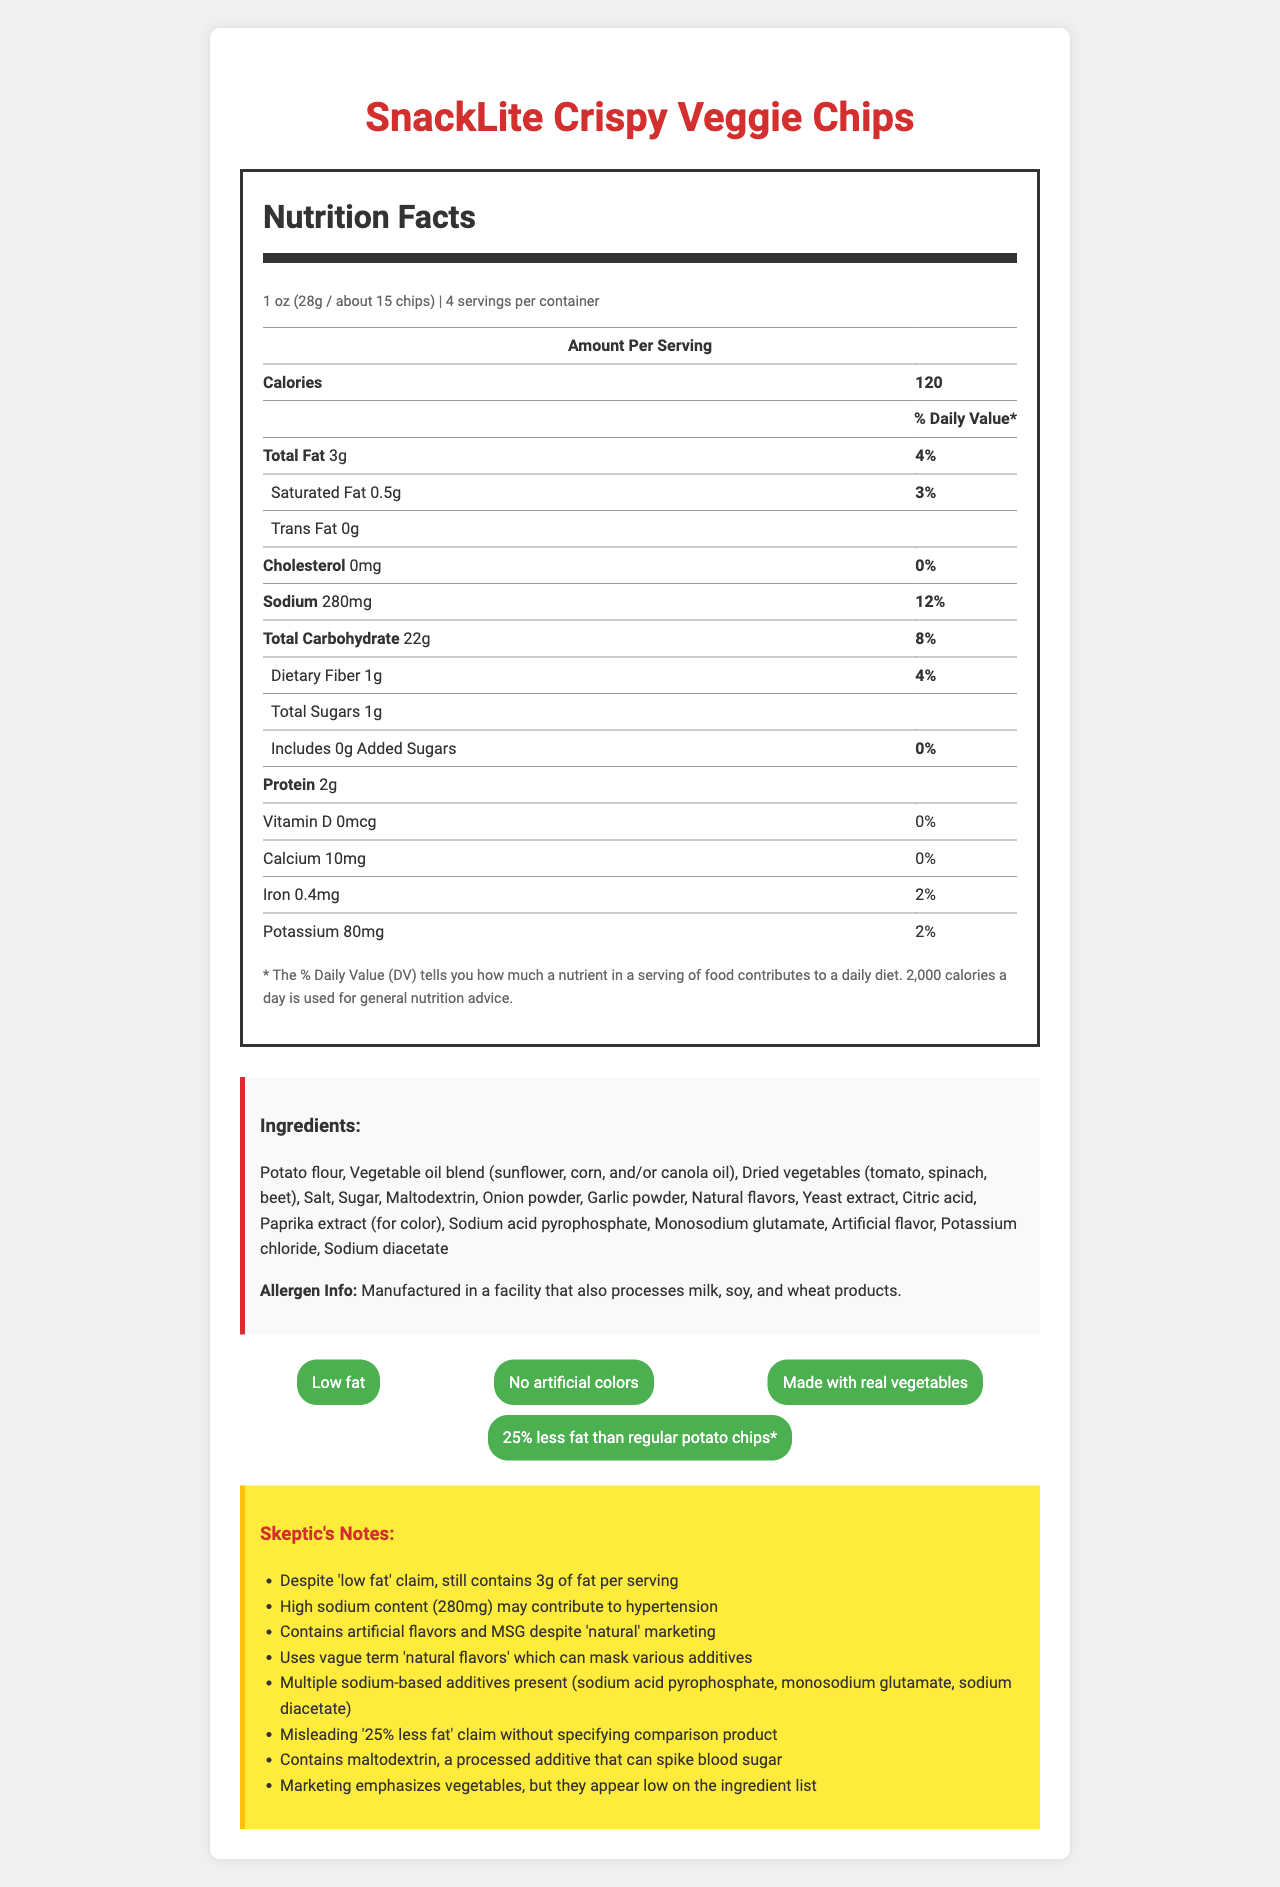what is the total fat content per serving? The Nutrition Facts section lists the total fat content as 3g per serving.
Answer: 3g how many servings are there per container? The Nutrition Facts section indicates there are 4 servings per container.
Answer: 4 what is the percentage daily value of sodium per serving? The Nutrition Facts section shows that the sodium percentage daily value is 12% per serving.
Answer: 12% name one artificial additive mentioned in the ingredients list. The ingredients list includes monosodium glutamate as one of the additives.
Answer: Monosodium glutamate what is the first ingredient listed? The first ingredient listed in the ingredients section is potato flour.
Answer: Potato flour how much potassium does one serving contain? The Nutrition Facts section indicates that one serving contains 80mg of potassium.
Answer: 80mg how many grams of protein are in one serving? The Nutrition Facts section shows that there are 2g of protein per serving.
Answer: 2g what is the main marketing claim mentioned? One of the key marketing claims emphasized is "Low fat."
Answer: Low fat which of the following is a true marketing claim? A. Contains artificial colors B. Made with real vegetables C. Contains high fiber D. No added sugars The marketing claims section states "Made with real vegetables."
Answer: B how many grams of dietary fiber are in one serving? A. 0g B. 1g C. 2g D. 3g The Nutrition Facts section indicates that one serving contains 1g of dietary fiber.
Answer: B does the product contain cholesterol? The Nutrition Facts section shows the product contains 0mg of cholesterol, indicating no cholesterol.
Answer: No describe the overall nutritional profile and ingredient content of SnackLite Crispy Veggie Chips. The description should summarize the main elements of the document, including both nutritional information and ingredient concerns.
Answer: SnackLite Crispy Veggie Chips are marketed as a low-fat snack with 3g of fat per serving. However, they contain a relatively high sodium content (280mg) and several artificial additives, including monosodium glutamate and artificial flavors. The chips are made with potato flour and a blend of vegetable oils, with some dried vegetables for flavor. Despite marketing claims, the product still contains processed ingredients like maltodextrin and multiple sodium-based additives. what are the exact quantities of vitamin D and calcium in one serving? The document provides the quantities but only lists 0% daily value for both vitamin D and calcium, without stating specific amounts.
Answer: Cannot be determined 